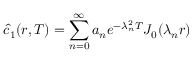Convert formula to latex. <formula><loc_0><loc_0><loc_500><loc_500>\hat { c } _ { 1 } ( r , T ) = \sum _ { n = 0 } ^ { \infty } a _ { n } e ^ { - \lambda _ { n } ^ { 2 } T } J _ { 0 } ( \lambda _ { n } r )</formula> 